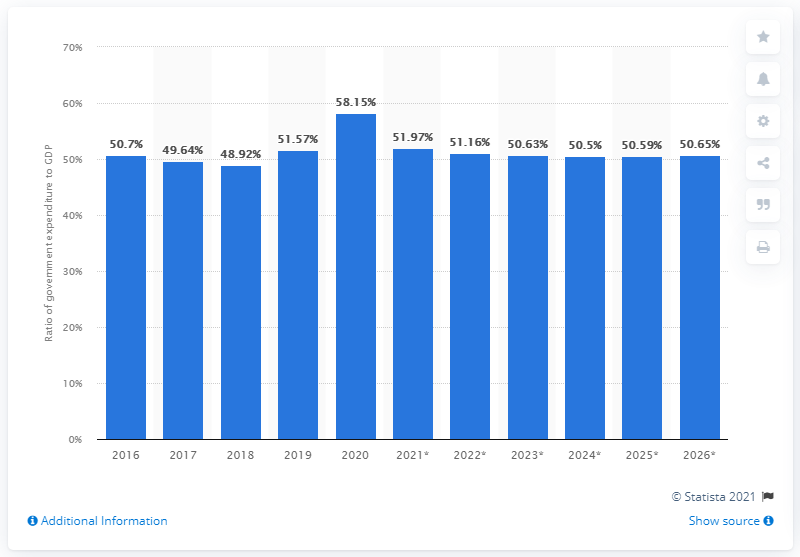Highlight a few significant elements in this photo. In the year 2020, the ratio of government expenditure to GDP changed. In 2020, a significant portion of Norway's GDP was allocated towards government expenditure, representing 58.15%. 